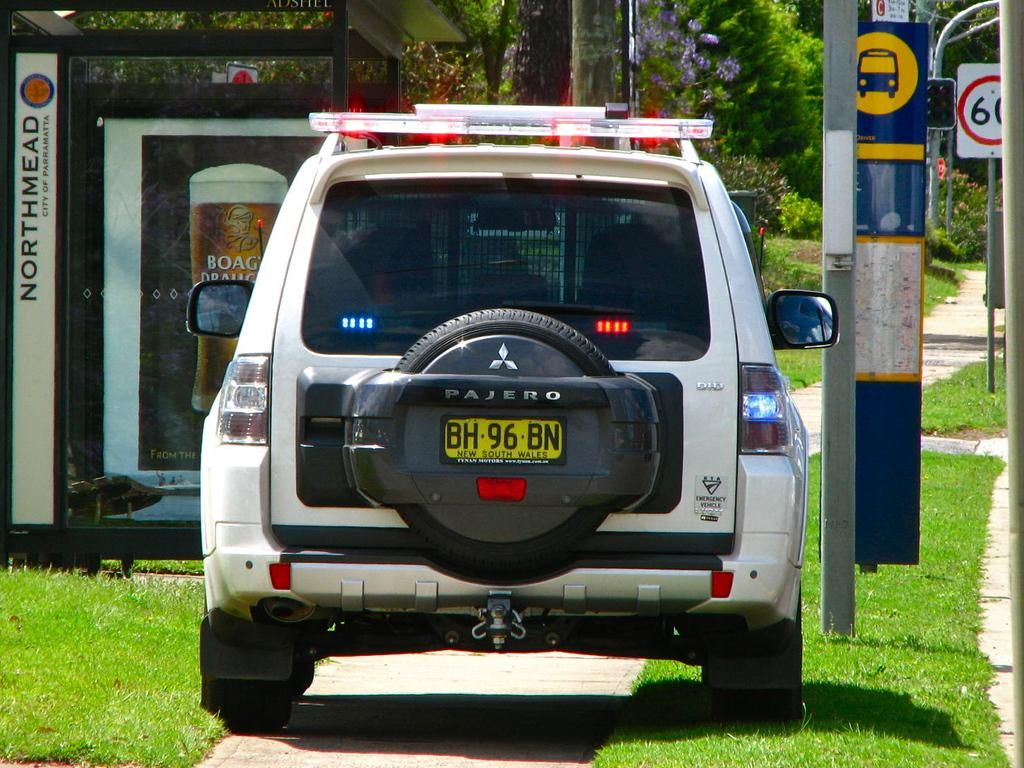What type of vehicle is visible in the image? There is a vehicle with lights in the image. Where is the vehicle located? The vehicle is parked on the ground. What can be seen in the background of the image? There is a banner with text, a group of trees, and a sign board in the background. What type of joke is being told by the trees in the image? There are no jokes being told by the trees in the image, as trees do not have the ability to tell jokes. 